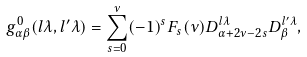<formula> <loc_0><loc_0><loc_500><loc_500>g _ { \alpha \beta } ^ { 0 } ( l \lambda , l ^ { \prime } \lambda ) = \sum _ { s = 0 } ^ { \nu } ( - 1 ) ^ { s } F _ { s } ( \nu ) D _ { \alpha + 2 \nu - 2 s } ^ { l \lambda } D _ { \beta } ^ { l ^ { \prime } \lambda } ,</formula> 